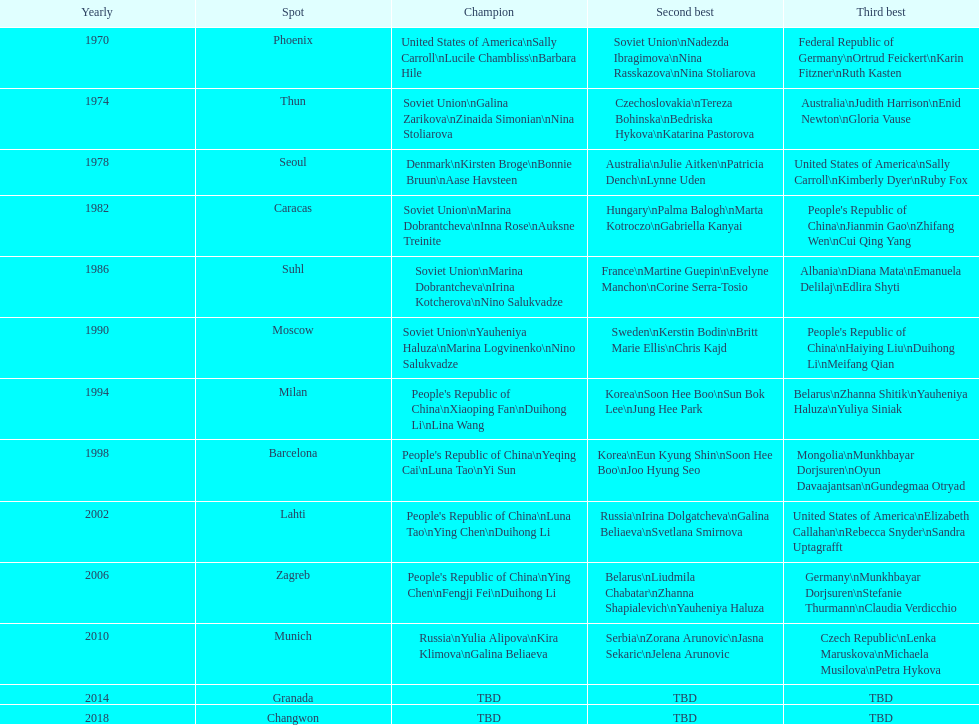Who is mentioned right before bonnie bruun in the gold column? Kirsten Broge. 